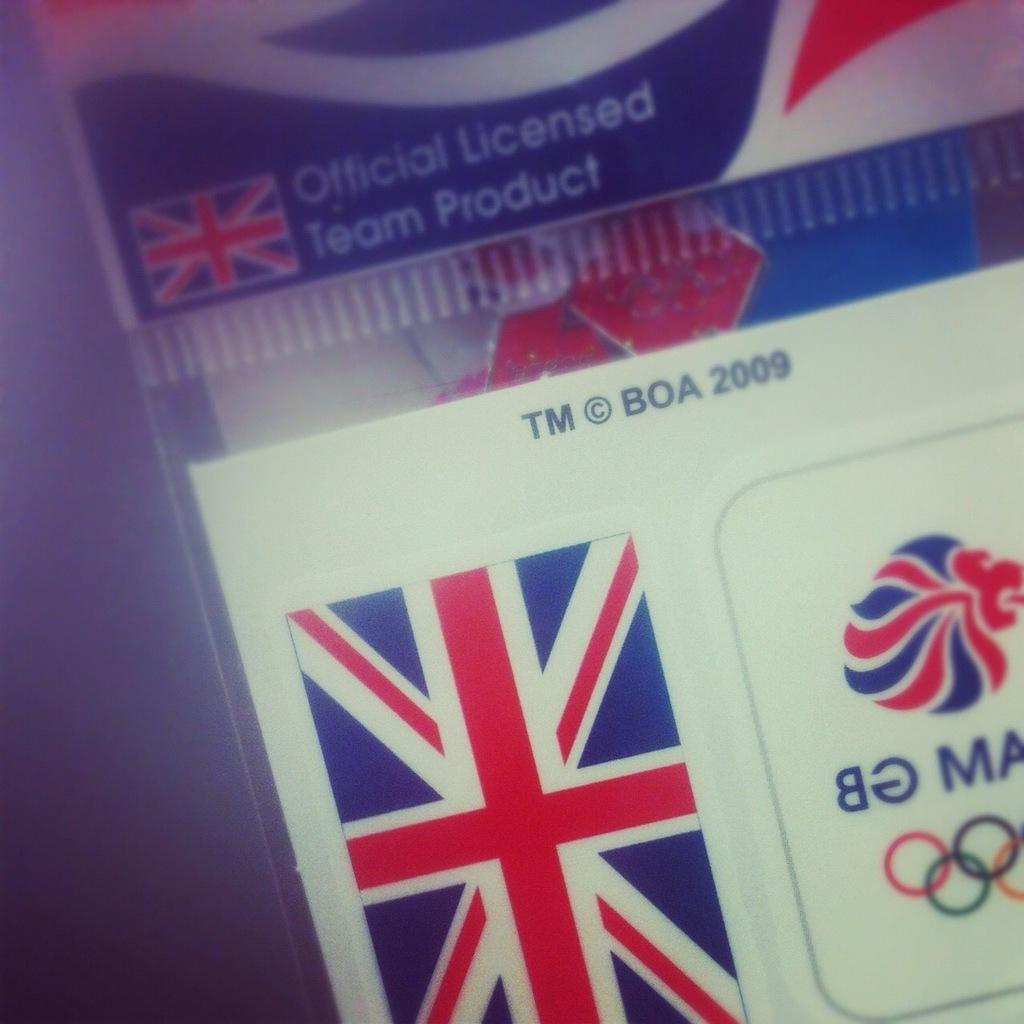What type of document is shown in the image? The image is a close view of an identity card. What national symbol can be seen on the card? There is an American flag visible on the card. What type of license is mentioned on the card? The text "Critical Licence" is written on the card. What type of dress is the person wearing in the image? There is no person visible in the image, as it is a close view of an identity card. Can you describe the skateboarding skills of the person in the image? There is no person or skateboarding activity present in the image; it is a close view of an identity card. 